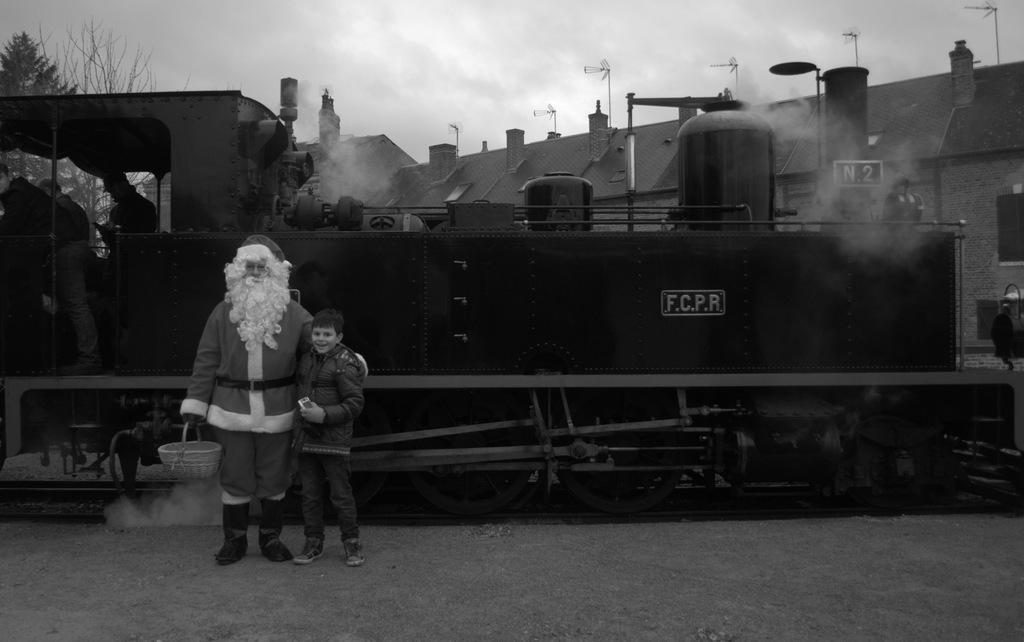Who is the main character in the image? There is Santa Claus in the image. What is Santa Claus doing in the image? Santa Claus is standing on the land. Is there anyone else in the image besides Santa Claus? Yes, there is a boy beside Santa Claus. What can be seen in the background of the image? There is a rail engine and clouds visible in the sky in the background of the image. What type of clock is visible on the rail engine in the image? There is no clock visible on the rail engine in the image. What type of judgment is Santa Claus making in the image? Santa Claus is not making any judgment in the image; he is simply standing on the land. 